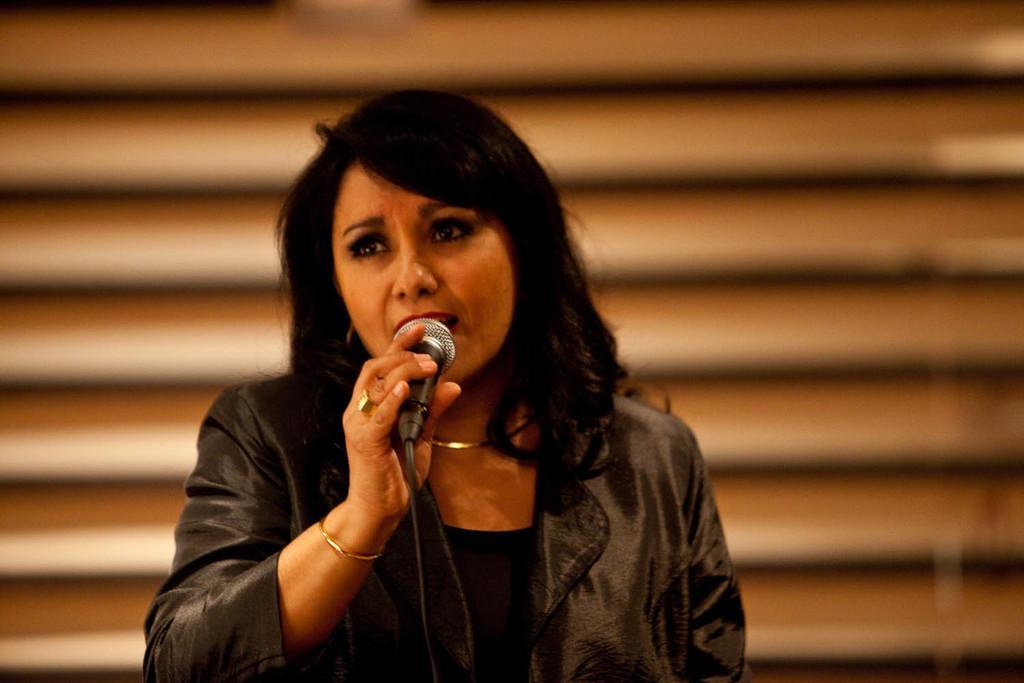Could you give a brief overview of what you see in this image? In this image in the center there is one woman standing, and she is holding a mike and it seems that she is singing. And in the background there might be a window. 